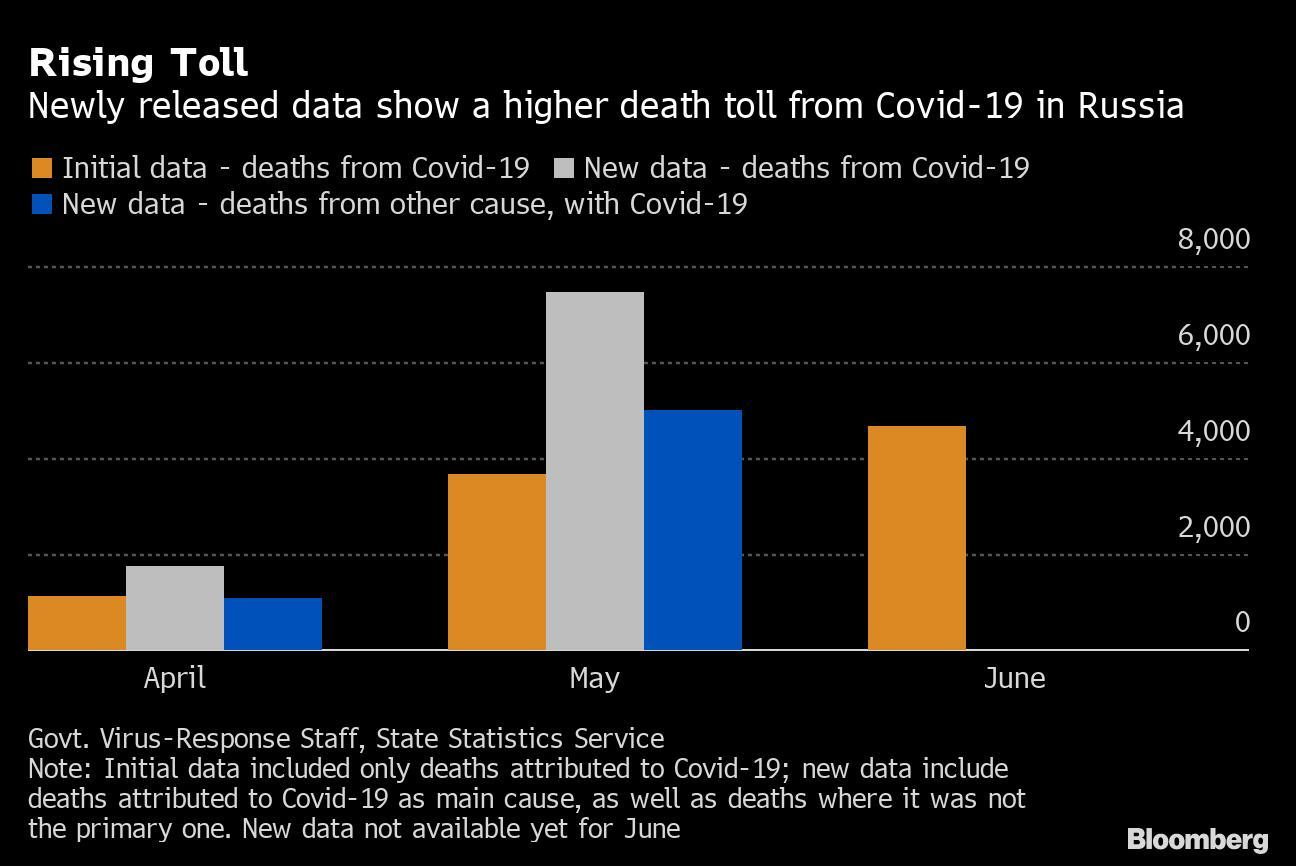Which colour is used to represent initial data - white, blue or yellow?
Answer the question with a short phrase. Yellow Which colour is used to represent 'new data -deaths from other cause with, covid-19' - white, blue or green? Blue In which month was the initial data higher than 4000? June In which month was the initial data lower than 2000? April The Covid-19 data of which three months are shown here? April, May, June In which month was the 'new data- deaths from covid-19', higher than 6000? May In which month was the 'new data- deaths from other cause, with covid-19' higher than 4000? May 